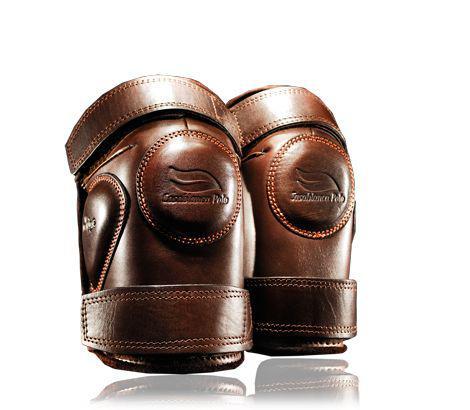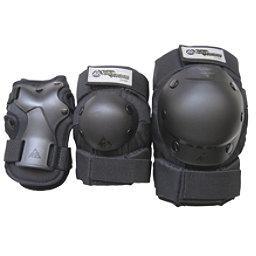The first image is the image on the left, the second image is the image on the right. Examine the images to the left and right. Is the description "The number of protective items are not an even number; it is an odd number." accurate? Answer yes or no. Yes. 